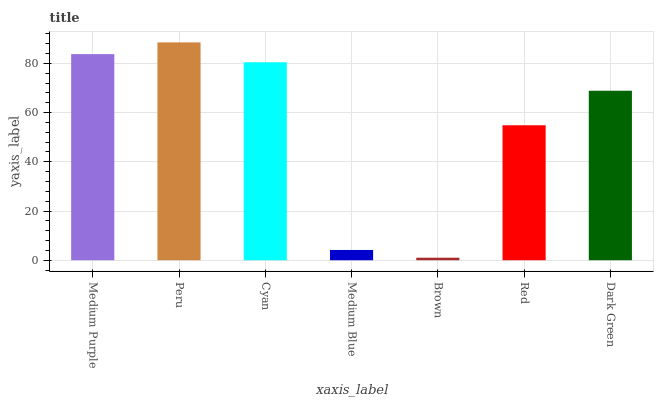Is Brown the minimum?
Answer yes or no. Yes. Is Peru the maximum?
Answer yes or no. Yes. Is Cyan the minimum?
Answer yes or no. No. Is Cyan the maximum?
Answer yes or no. No. Is Peru greater than Cyan?
Answer yes or no. Yes. Is Cyan less than Peru?
Answer yes or no. Yes. Is Cyan greater than Peru?
Answer yes or no. No. Is Peru less than Cyan?
Answer yes or no. No. Is Dark Green the high median?
Answer yes or no. Yes. Is Dark Green the low median?
Answer yes or no. Yes. Is Medium Blue the high median?
Answer yes or no. No. Is Medium Blue the low median?
Answer yes or no. No. 